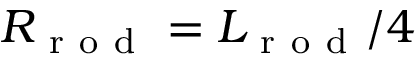<formula> <loc_0><loc_0><loc_500><loc_500>R _ { r o d } = L _ { r o d } / 4</formula> 